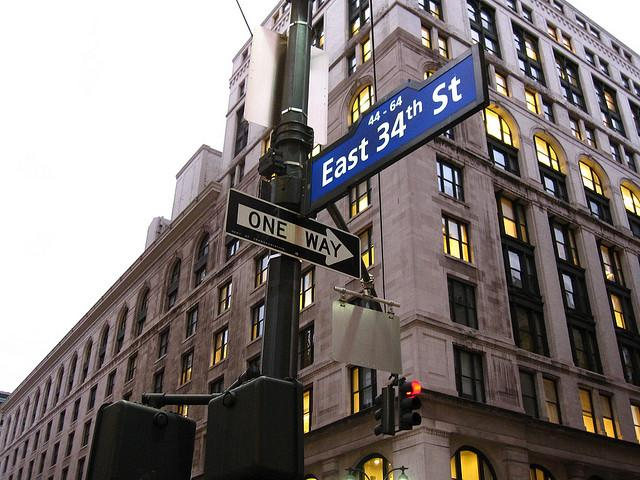What are is the image from? new york 